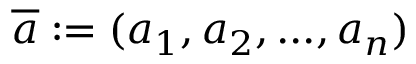<formula> <loc_0><loc_0><loc_500><loc_500>{ \overline { a } } \colon = ( a _ { 1 } , a _ { 2 } , \dots , a _ { n } )</formula> 